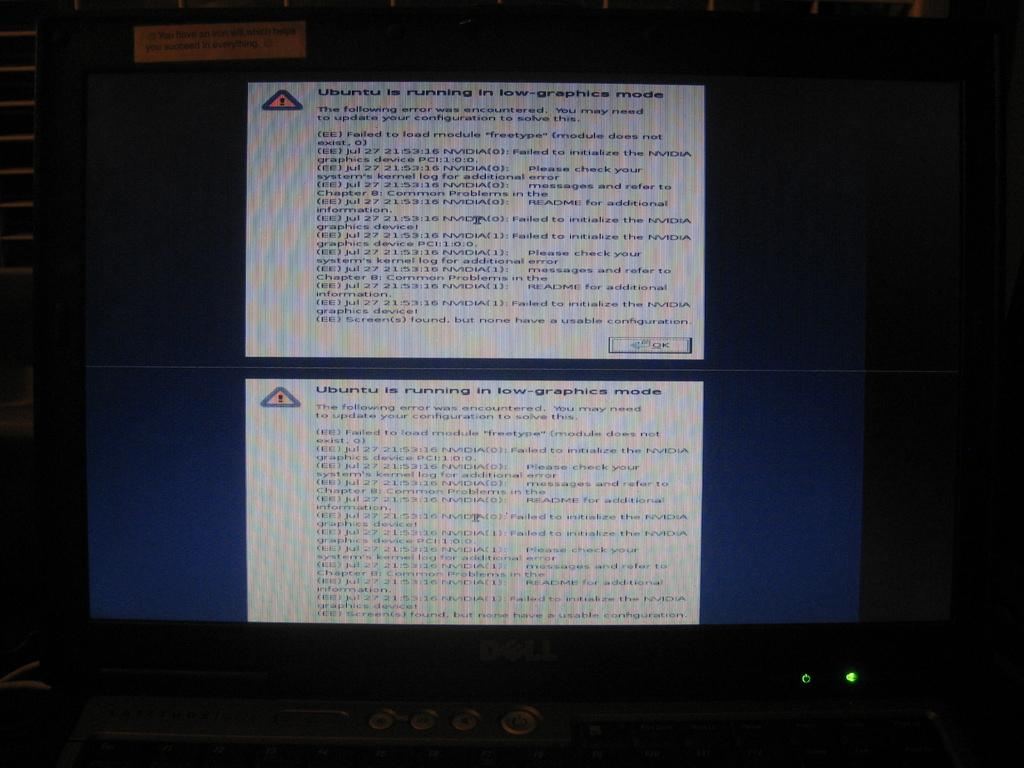<image>
Describe the image concisely. Computer screen displaying an error that Ubuntu is running in low-graphics mode 